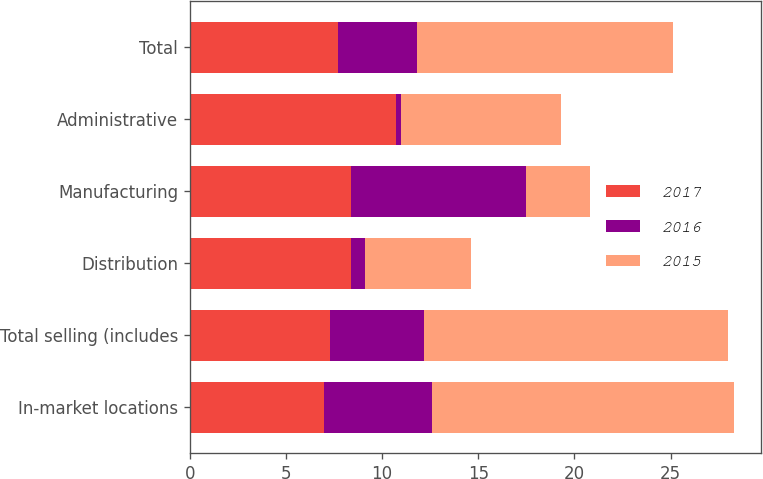<chart> <loc_0><loc_0><loc_500><loc_500><stacked_bar_chart><ecel><fcel>In-market locations<fcel>Total selling (includes<fcel>Distribution<fcel>Manufacturing<fcel>Administrative<fcel>Total<nl><fcel>2017<fcel>7<fcel>7.3<fcel>8.4<fcel>8.4<fcel>10.7<fcel>7.7<nl><fcel>2016<fcel>5.6<fcel>4.9<fcel>0.7<fcel>9.1<fcel>0.3<fcel>4.1<nl><fcel>2015<fcel>15.7<fcel>15.8<fcel>5.5<fcel>3.3<fcel>8.3<fcel>13.3<nl></chart> 